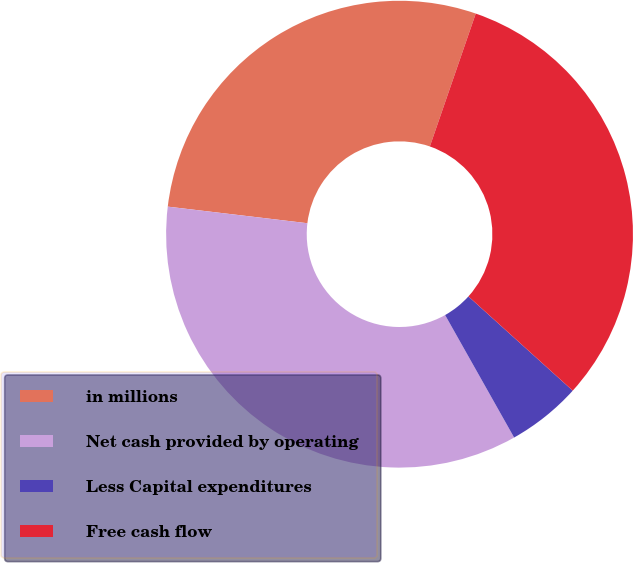Convert chart to OTSL. <chart><loc_0><loc_0><loc_500><loc_500><pie_chart><fcel>in millions<fcel>Net cash provided by operating<fcel>Less Capital expenditures<fcel>Free cash flow<nl><fcel>28.41%<fcel>35.05%<fcel>5.14%<fcel>31.4%<nl></chart> 